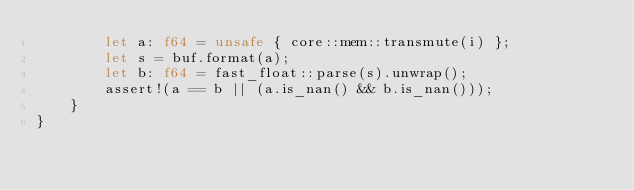<code> <loc_0><loc_0><loc_500><loc_500><_Rust_>        let a: f64 = unsafe { core::mem::transmute(i) };
        let s = buf.format(a);
        let b: f64 = fast_float::parse(s).unwrap();
        assert!(a == b || (a.is_nan() && b.is_nan()));
    }
}
</code> 